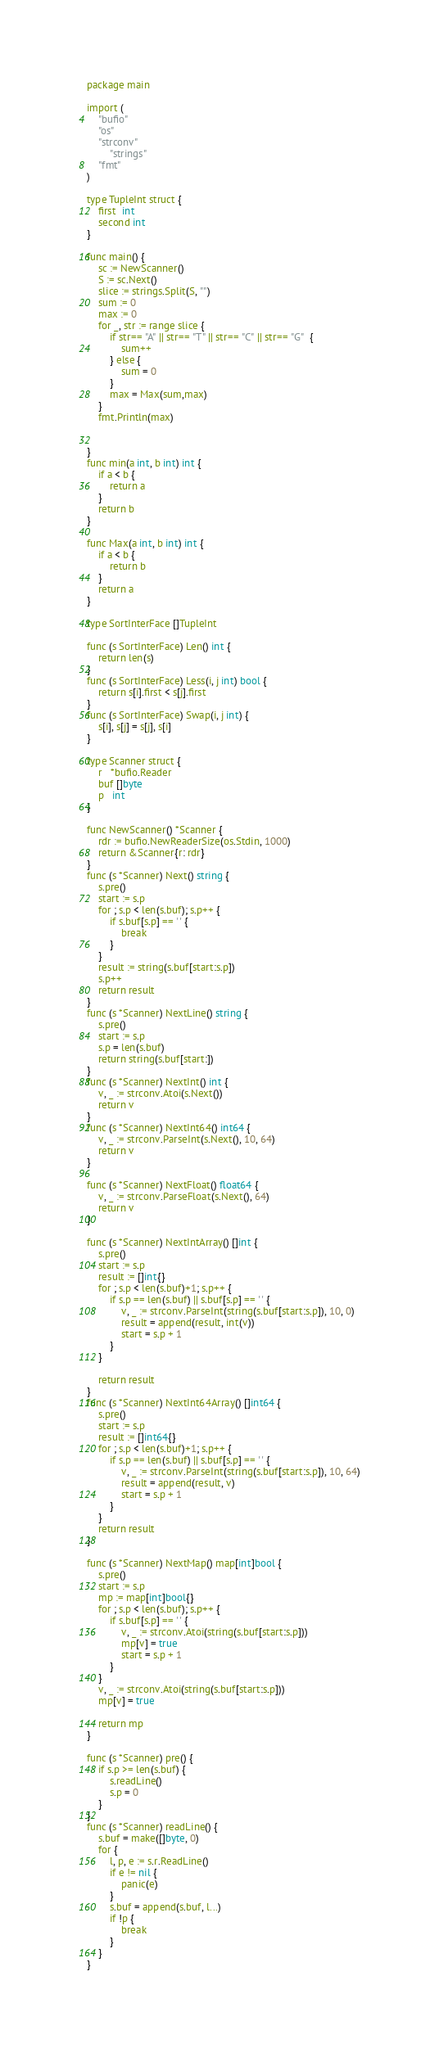Convert code to text. <code><loc_0><loc_0><loc_500><loc_500><_Go_>package main

import (
	"bufio"
	"os"
	"strconv"
		"strings"
	"fmt"
)

type TupleInt struct {
	first  int
	second int
}

func main() {
	sc := NewScanner()
	S := sc.Next()
	slice := strings.Split(S, "")
	sum := 0
	max := 0
	for _, str := range slice {
		if str== "A" || str== "T" || str== "C" || str== "G"  {
			sum++
		} else {
			sum = 0
		}
		max = Max(sum,max)
	}
	fmt.Println(max)


}
func min(a int, b int) int {
	if a < b {
		return a
	}
	return b
}

func Max(a int, b int) int {
	if a < b {
		return b
	}
	return a
}

type SortInterFace []TupleInt

func (s SortInterFace) Len() int {
	return len(s)
}
func (s SortInterFace) Less(i, j int) bool {
	return s[i].first < s[j].first
}
func (s SortInterFace) Swap(i, j int) {
	s[i], s[j] = s[j], s[i]
}

type Scanner struct {
	r   *bufio.Reader
	buf []byte
	p   int
}

func NewScanner() *Scanner {
	rdr := bufio.NewReaderSize(os.Stdin, 1000)
	return &Scanner{r: rdr}
}
func (s *Scanner) Next() string {
	s.pre()
	start := s.p
	for ; s.p < len(s.buf); s.p++ {
		if s.buf[s.p] == ' ' {
			break
		}
	}
	result := string(s.buf[start:s.p])
	s.p++
	return result
}
func (s *Scanner) NextLine() string {
	s.pre()
	start := s.p
	s.p = len(s.buf)
	return string(s.buf[start:])
}
func (s *Scanner) NextInt() int {
	v, _ := strconv.Atoi(s.Next())
	return v
}
func (s *Scanner) NextInt64() int64 {
	v, _ := strconv.ParseInt(s.Next(), 10, 64)
	return v
}

func (s *Scanner) NextFloat() float64 {
	v, _ := strconv.ParseFloat(s.Next(), 64)
	return v
}

func (s *Scanner) NextIntArray() []int {
	s.pre()
	start := s.p
	result := []int{}
	for ; s.p < len(s.buf)+1; s.p++ {
		if s.p == len(s.buf) || s.buf[s.p] == ' ' {
			v, _ := strconv.ParseInt(string(s.buf[start:s.p]), 10, 0)
			result = append(result, int(v))
			start = s.p + 1
		}
	}

	return result
}
func (s *Scanner) NextInt64Array() []int64 {
	s.pre()
	start := s.p
	result := []int64{}
	for ; s.p < len(s.buf)+1; s.p++ {
		if s.p == len(s.buf) || s.buf[s.p] == ' ' {
			v, _ := strconv.ParseInt(string(s.buf[start:s.p]), 10, 64)
			result = append(result, v)
			start = s.p + 1
		}
	}
	return result
}

func (s *Scanner) NextMap() map[int]bool {
	s.pre()
	start := s.p
	mp := map[int]bool{}
	for ; s.p < len(s.buf); s.p++ {
		if s.buf[s.p] == ' ' {
			v, _ := strconv.Atoi(string(s.buf[start:s.p]))
			mp[v] = true
			start = s.p + 1
		}
	}
	v, _ := strconv.Atoi(string(s.buf[start:s.p]))
	mp[v] = true

	return mp
}

func (s *Scanner) pre() {
	if s.p >= len(s.buf) {
		s.readLine()
		s.p = 0
	}
}
func (s *Scanner) readLine() {
	s.buf = make([]byte, 0)
	for {
		l, p, e := s.r.ReadLine()
		if e != nil {
			panic(e)
		}
		s.buf = append(s.buf, l...)
		if !p {
			break
		}
	}
}
</code> 